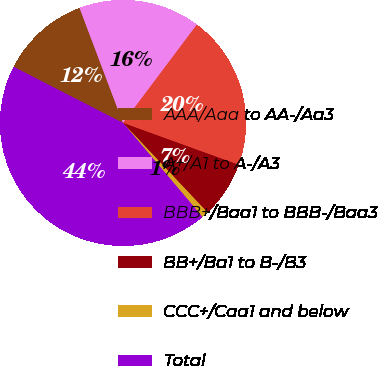Convert chart. <chart><loc_0><loc_0><loc_500><loc_500><pie_chart><fcel>AAA/Aaa to AA-/Aa3<fcel>A+/A1 to A-/A3<fcel>BBB+/Baa1 to BBB-/Baa3<fcel>BB+/Ba1 to B-/B3<fcel>CCC+/Caa1 and below<fcel>Total<nl><fcel>11.71%<fcel>16.0%<fcel>20.28%<fcel>7.43%<fcel>0.87%<fcel>43.71%<nl></chart> 